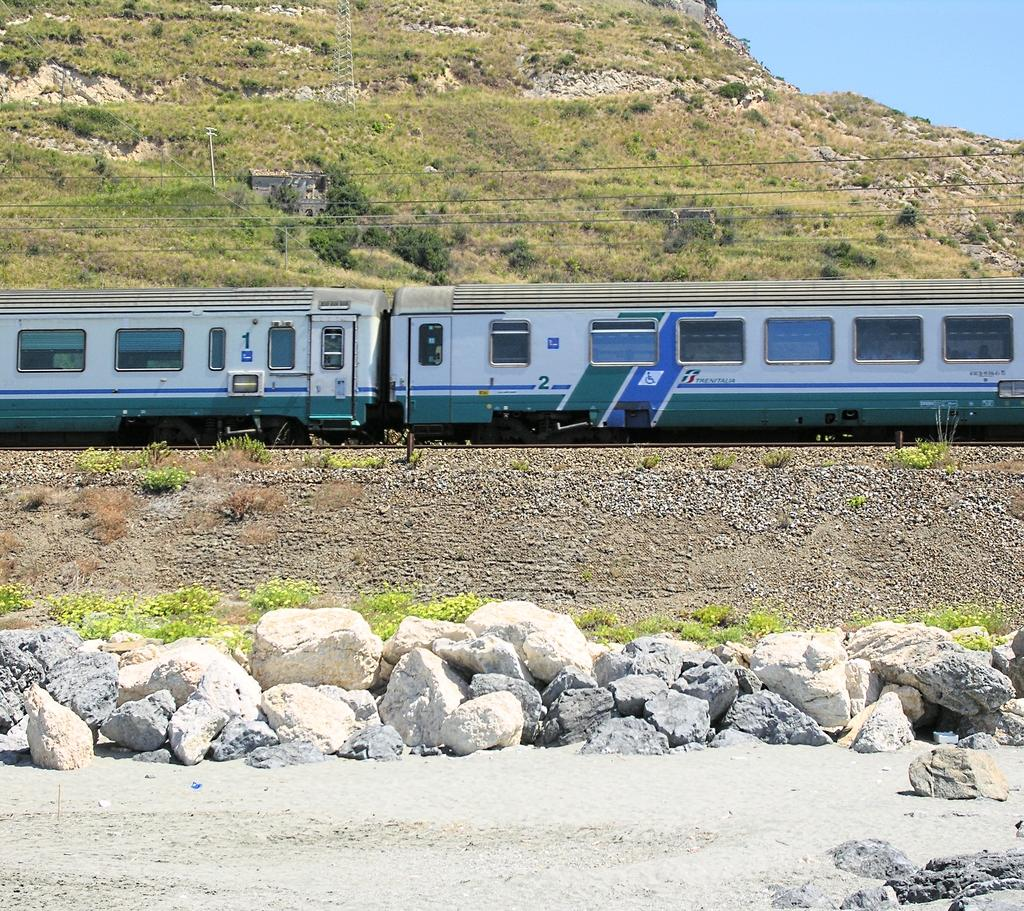What type of natural elements can be seen in the image? There are rocks and soil visible in the image. What man-made object can be seen moving in the image? There is a train moving on a track in the image. What else can be seen in the image besides the train? There are wires visible in the image. What is the background of the image? There is a mountain in the background of the image. What is the condition of the sky in the image? The sky is clear in the image. What type of ice can be seen melting on the guitar in the image? There is no ice or guitar present in the image. 